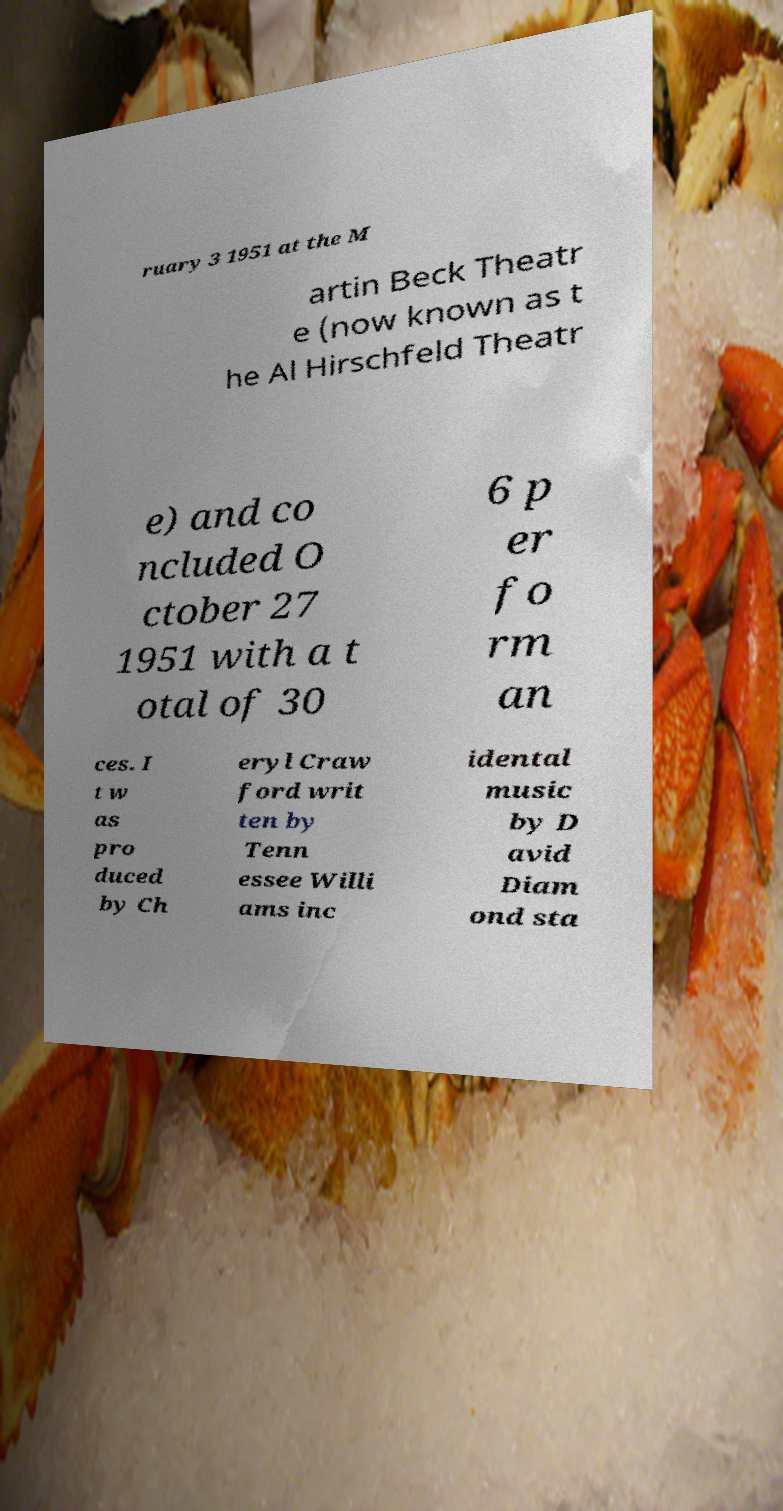Could you extract and type out the text from this image? ruary 3 1951 at the M artin Beck Theatr e (now known as t he Al Hirschfeld Theatr e) and co ncluded O ctober 27 1951 with a t otal of 30 6 p er fo rm an ces. I t w as pro duced by Ch eryl Craw ford writ ten by Tenn essee Willi ams inc idental music by D avid Diam ond sta 